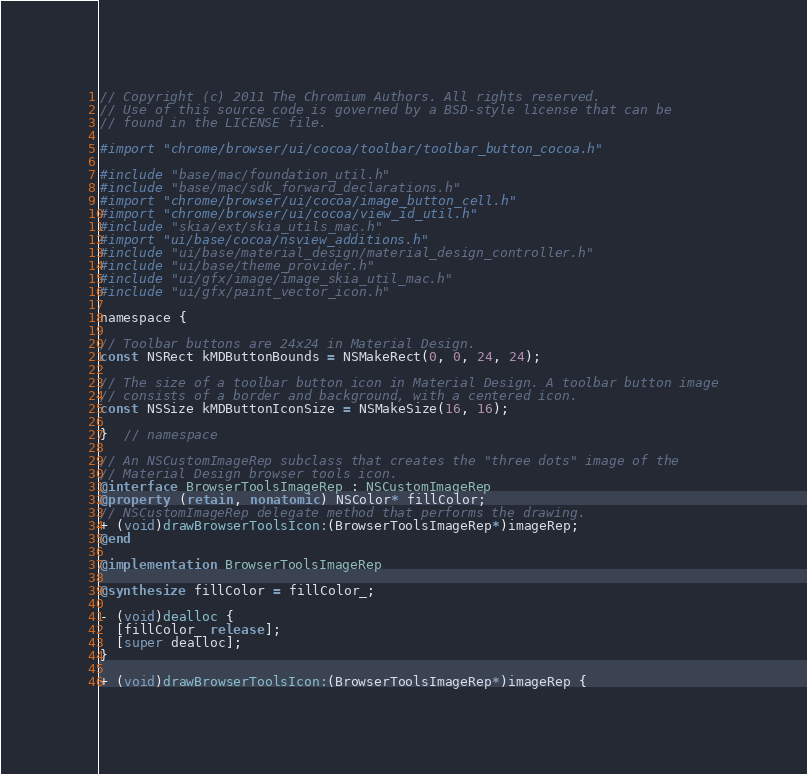Convert code to text. <code><loc_0><loc_0><loc_500><loc_500><_ObjectiveC_>// Copyright (c) 2011 The Chromium Authors. All rights reserved.
// Use of this source code is governed by a BSD-style license that can be
// found in the LICENSE file.

#import "chrome/browser/ui/cocoa/toolbar/toolbar_button_cocoa.h"

#include "base/mac/foundation_util.h"
#include "base/mac/sdk_forward_declarations.h"
#import "chrome/browser/ui/cocoa/image_button_cell.h"
#import "chrome/browser/ui/cocoa/view_id_util.h"
#include "skia/ext/skia_utils_mac.h"
#import "ui/base/cocoa/nsview_additions.h"
#include "ui/base/material_design/material_design_controller.h"
#include "ui/base/theme_provider.h"
#include "ui/gfx/image/image_skia_util_mac.h"
#include "ui/gfx/paint_vector_icon.h"

namespace {

// Toolbar buttons are 24x24 in Material Design.
const NSRect kMDButtonBounds = NSMakeRect(0, 0, 24, 24);

// The size of a toolbar button icon in Material Design. A toolbar button image
// consists of a border and background, with a centered icon.
const NSSize kMDButtonIconSize = NSMakeSize(16, 16);

}  // namespace

// An NSCustomImageRep subclass that creates the "three dots" image of the
// Material Design browser tools icon.
@interface BrowserToolsImageRep : NSCustomImageRep
@property (retain, nonatomic) NSColor* fillColor;
// NSCustomImageRep delegate method that performs the drawing.
+ (void)drawBrowserToolsIcon:(BrowserToolsImageRep*)imageRep;
@end

@implementation BrowserToolsImageRep

@synthesize fillColor = fillColor_;

- (void)dealloc {
  [fillColor_ release];
  [super dealloc];
}

+ (void)drawBrowserToolsIcon:(BrowserToolsImageRep*)imageRep {</code> 